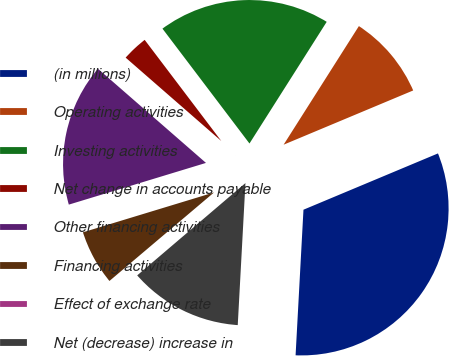Convert chart to OTSL. <chart><loc_0><loc_0><loc_500><loc_500><pie_chart><fcel>(in millions)<fcel>Operating activities<fcel>Investing activities<fcel>Net change in accounts payable<fcel>Other financing activities<fcel>Financing activities<fcel>Effect of exchange rate<fcel>Net (decrease) increase in<nl><fcel>32.17%<fcel>9.69%<fcel>19.32%<fcel>3.27%<fcel>16.11%<fcel>6.48%<fcel>0.06%<fcel>12.9%<nl></chart> 